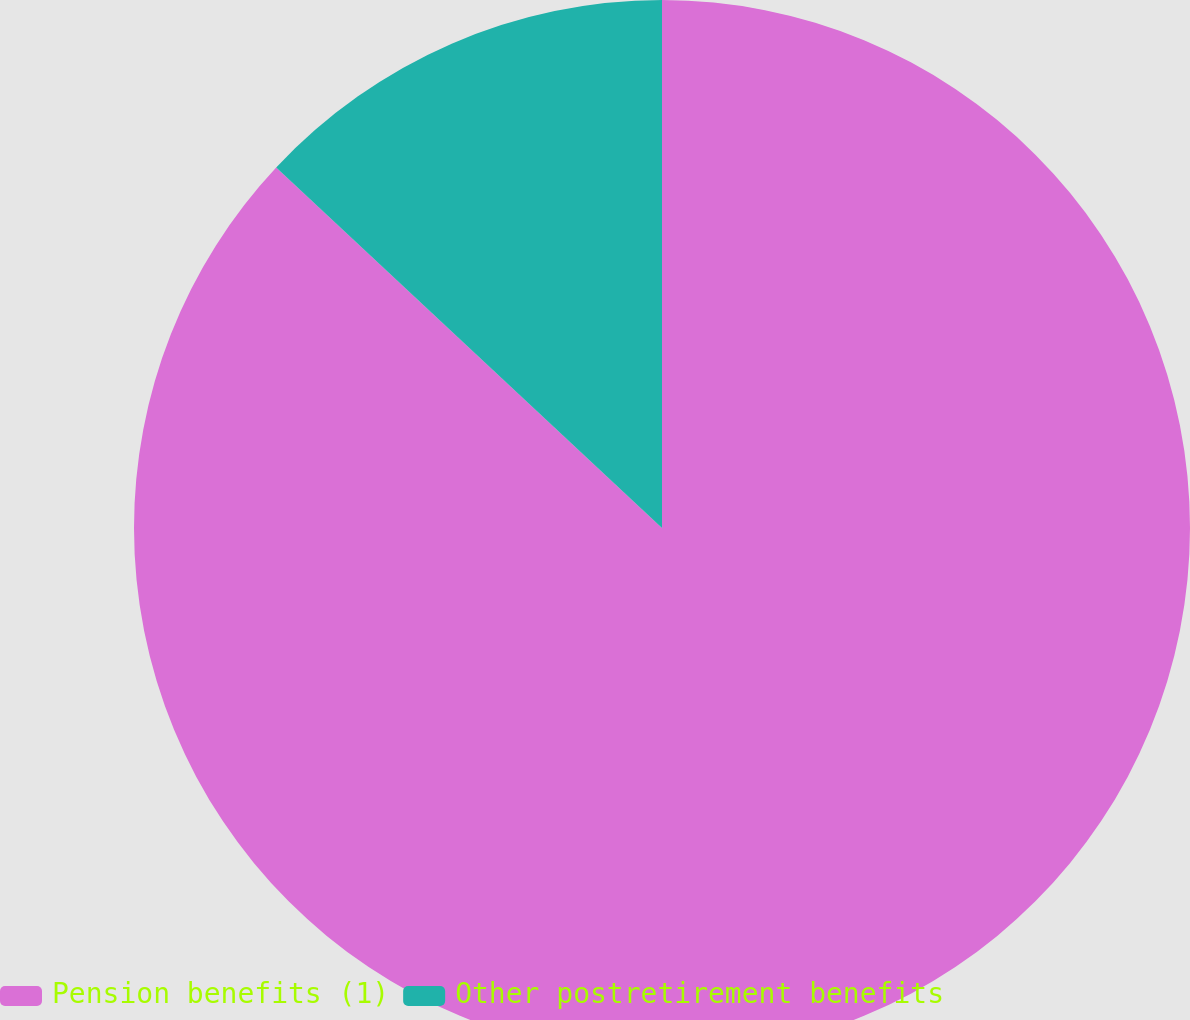Convert chart to OTSL. <chart><loc_0><loc_0><loc_500><loc_500><pie_chart><fcel>Pension benefits (1)<fcel>Other postretirement benefits<nl><fcel>86.96%<fcel>13.04%<nl></chart> 